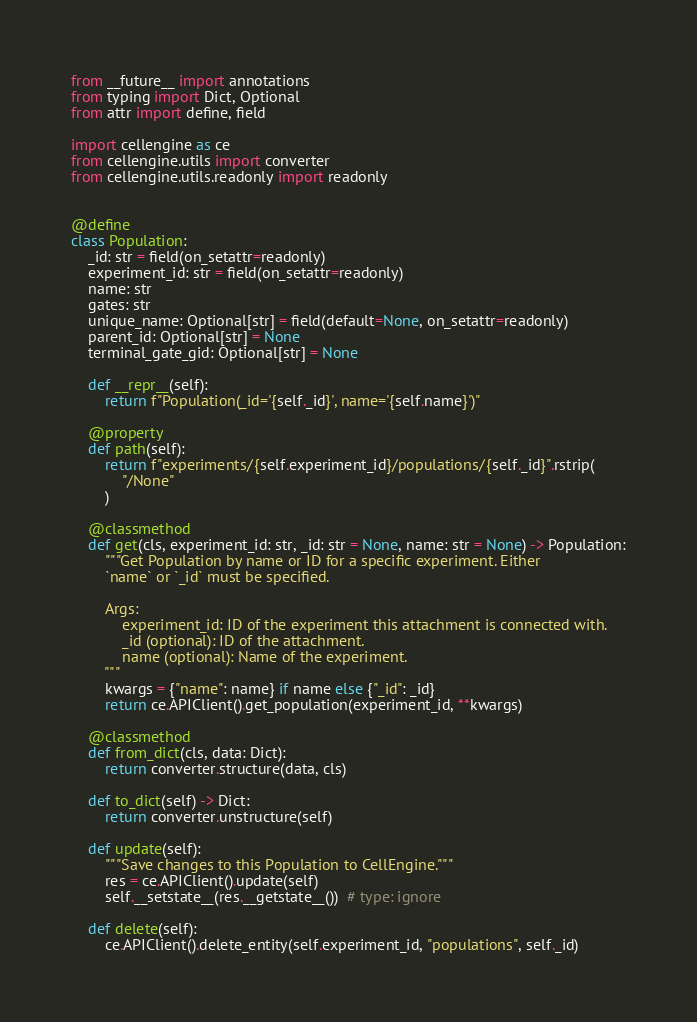<code> <loc_0><loc_0><loc_500><loc_500><_Python_>from __future__ import annotations
from typing import Dict, Optional
from attr import define, field

import cellengine as ce
from cellengine.utils import converter
from cellengine.utils.readonly import readonly


@define
class Population:
    _id: str = field(on_setattr=readonly)
    experiment_id: str = field(on_setattr=readonly)
    name: str
    gates: str
    unique_name: Optional[str] = field(default=None, on_setattr=readonly)
    parent_id: Optional[str] = None
    terminal_gate_gid: Optional[str] = None

    def __repr__(self):
        return f"Population(_id='{self._id}', name='{self.name}')"

    @property
    def path(self):
        return f"experiments/{self.experiment_id}/populations/{self._id}".rstrip(
            "/None"
        )

    @classmethod
    def get(cls, experiment_id: str, _id: str = None, name: str = None) -> Population:
        """Get Population by name or ID for a specific experiment. Either
        `name` or `_id` must be specified.

        Args:
            experiment_id: ID of the experiment this attachment is connected with.
            _id (optional): ID of the attachment.
            name (optional): Name of the experiment.
        """
        kwargs = {"name": name} if name else {"_id": _id}
        return ce.APIClient().get_population(experiment_id, **kwargs)

    @classmethod
    def from_dict(cls, data: Dict):
        return converter.structure(data, cls)

    def to_dict(self) -> Dict:
        return converter.unstructure(self)

    def update(self):
        """Save changes to this Population to CellEngine."""
        res = ce.APIClient().update(self)
        self.__setstate__(res.__getstate__())  # type: ignore

    def delete(self):
        ce.APIClient().delete_entity(self.experiment_id, "populations", self._id)
</code> 